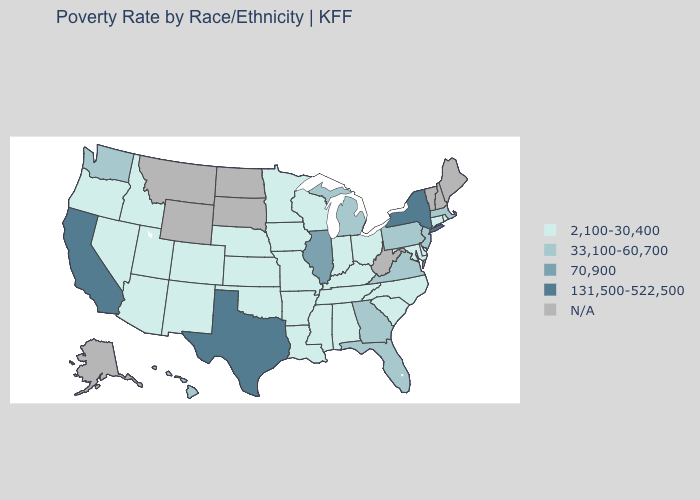Does Florida have the lowest value in the South?
Be succinct. No. How many symbols are there in the legend?
Short answer required. 5. Does Michigan have the lowest value in the USA?
Give a very brief answer. No. How many symbols are there in the legend?
Keep it brief. 5. Which states hav the highest value in the Northeast?
Keep it brief. New York. How many symbols are there in the legend?
Give a very brief answer. 5. What is the lowest value in states that border Illinois?
Be succinct. 2,100-30,400. Name the states that have a value in the range 131,500-522,500?
Write a very short answer. California, New York, Texas. How many symbols are there in the legend?
Write a very short answer. 5. Does the map have missing data?
Quick response, please. Yes. Does Kentucky have the highest value in the USA?
Short answer required. No. Does California have the highest value in the USA?
Concise answer only. Yes. Does California have the highest value in the West?
Write a very short answer. Yes. Name the states that have a value in the range 70,900?
Concise answer only. Illinois. 